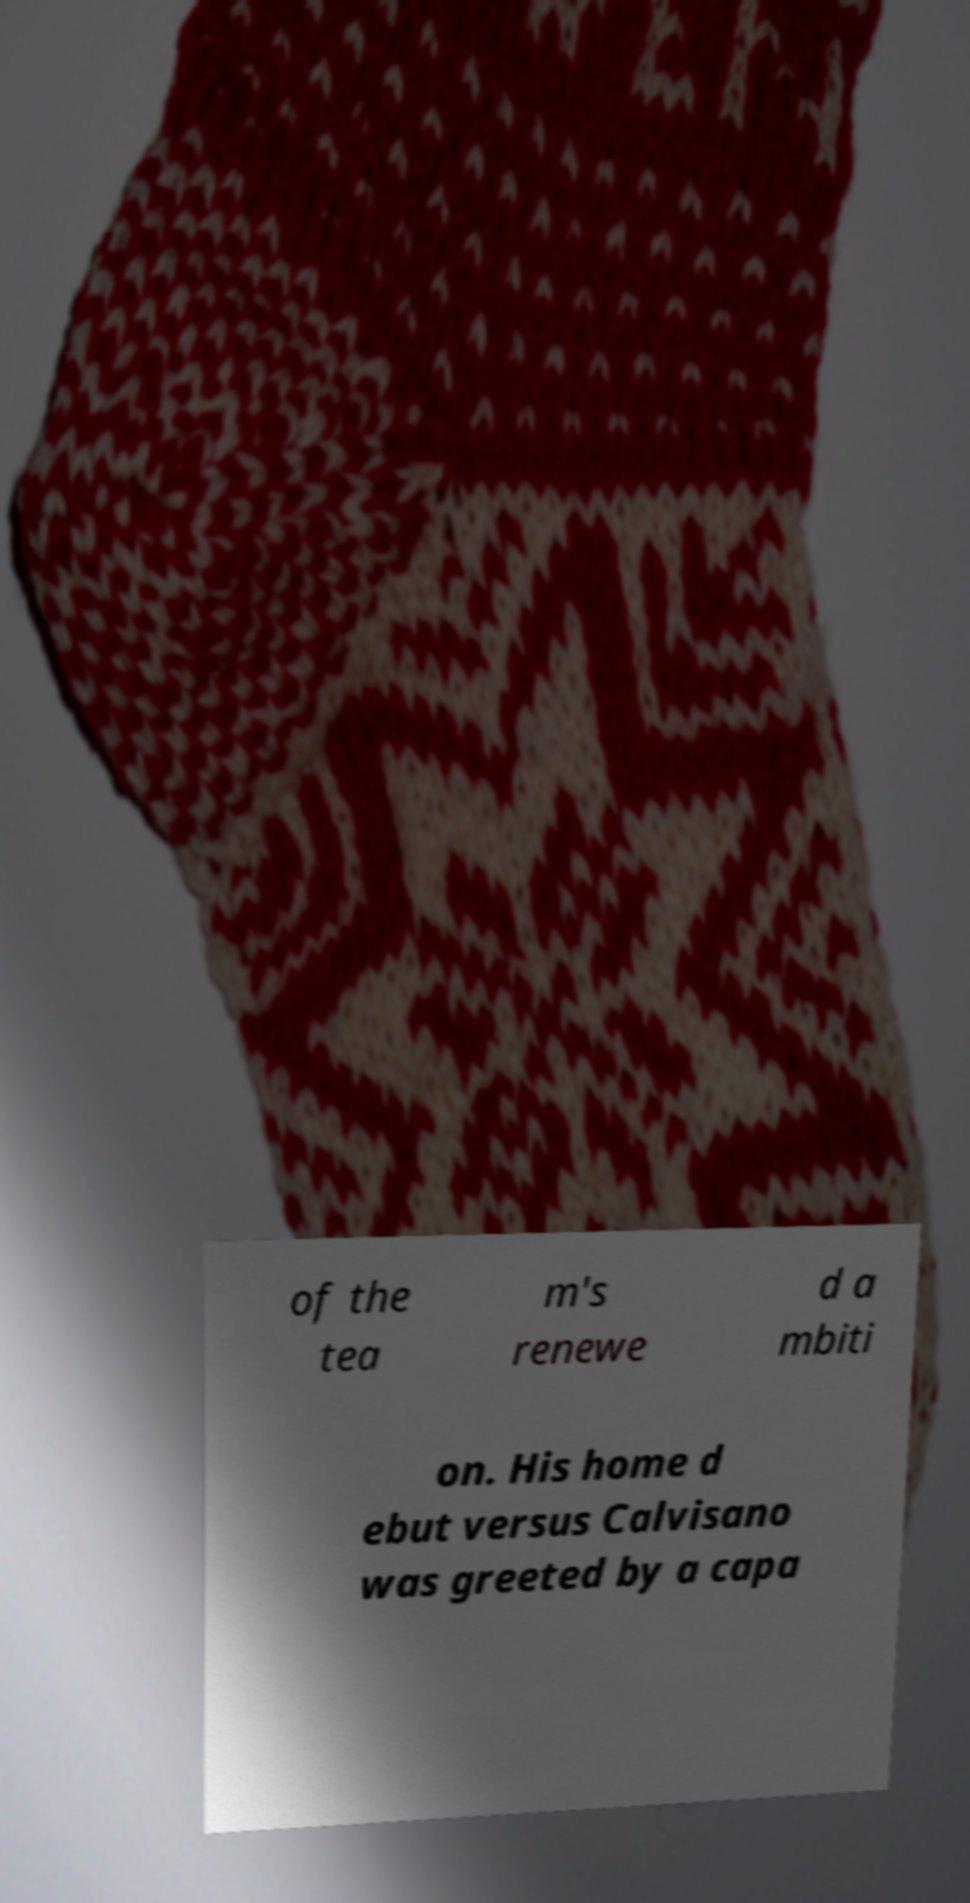I need the written content from this picture converted into text. Can you do that? of the tea m's renewe d a mbiti on. His home d ebut versus Calvisano was greeted by a capa 